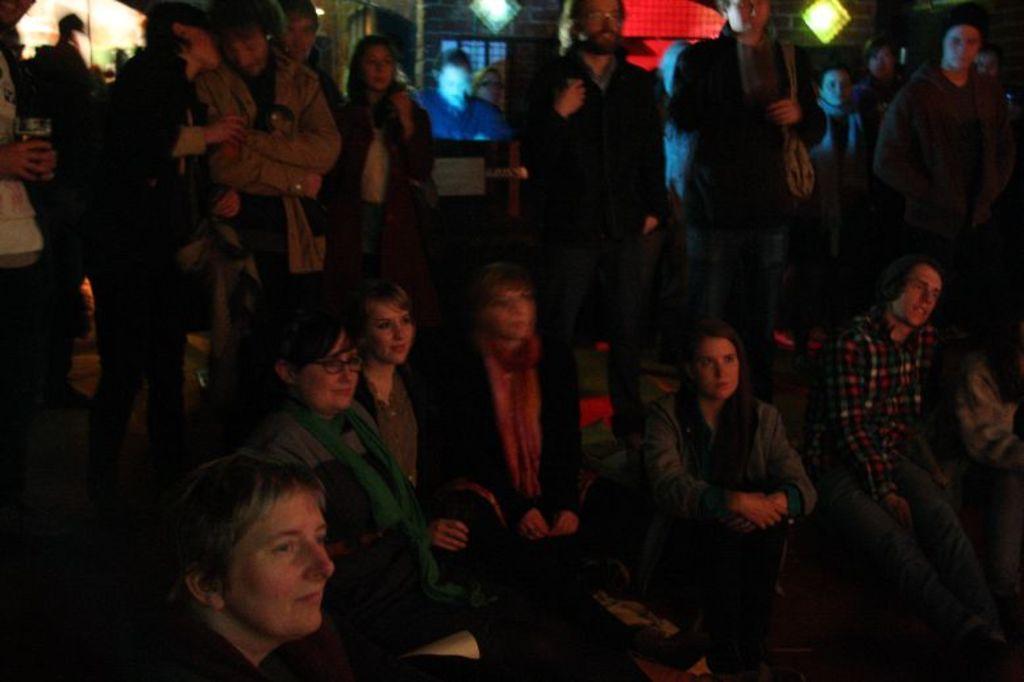Could you give a brief overview of what you see in this image? In this picture I can see few people are sitting and few are standing. I can see few lights and looks like a screen displaying in the background. 